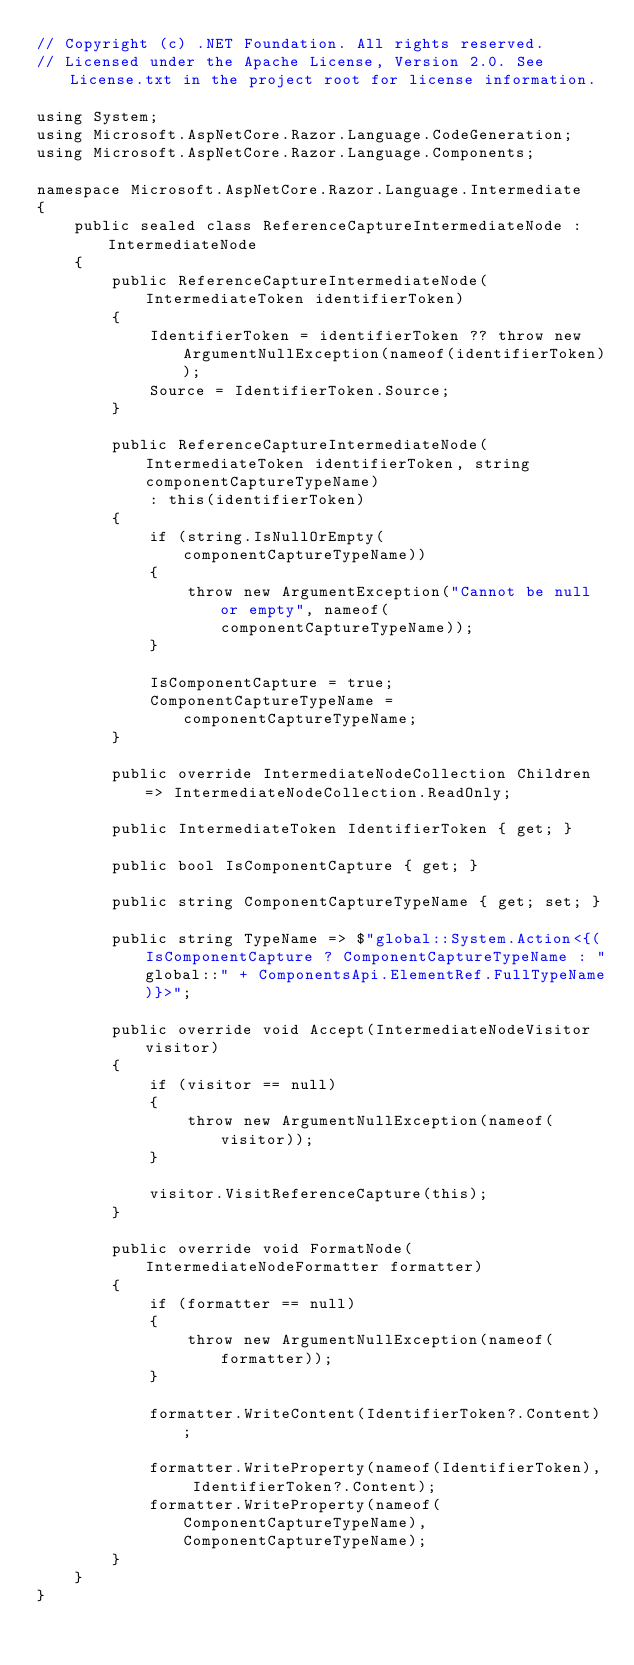<code> <loc_0><loc_0><loc_500><loc_500><_C#_>// Copyright (c) .NET Foundation. All rights reserved.
// Licensed under the Apache License, Version 2.0. See License.txt in the project root for license information.

using System;
using Microsoft.AspNetCore.Razor.Language.CodeGeneration;
using Microsoft.AspNetCore.Razor.Language.Components;

namespace Microsoft.AspNetCore.Razor.Language.Intermediate
{
    public sealed class ReferenceCaptureIntermediateNode : IntermediateNode
    {
        public ReferenceCaptureIntermediateNode(IntermediateToken identifierToken)
        {
            IdentifierToken = identifierToken ?? throw new ArgumentNullException(nameof(identifierToken));
            Source = IdentifierToken.Source;
        }

        public ReferenceCaptureIntermediateNode(IntermediateToken identifierToken, string componentCaptureTypeName)
            : this(identifierToken)
        {
            if (string.IsNullOrEmpty(componentCaptureTypeName))
            {
                throw new ArgumentException("Cannot be null or empty", nameof(componentCaptureTypeName));
            }

            IsComponentCapture = true;
            ComponentCaptureTypeName = componentCaptureTypeName;
        }

        public override IntermediateNodeCollection Children => IntermediateNodeCollection.ReadOnly;

        public IntermediateToken IdentifierToken { get; }

        public bool IsComponentCapture { get; }

        public string ComponentCaptureTypeName { get; set; }

        public string TypeName => $"global::System.Action<{(IsComponentCapture ? ComponentCaptureTypeName : "global::" + ComponentsApi.ElementRef.FullTypeName)}>";

        public override void Accept(IntermediateNodeVisitor visitor)
        {
            if (visitor == null)
            {
                throw new ArgumentNullException(nameof(visitor));
            }

            visitor.VisitReferenceCapture(this);
        }

        public override void FormatNode(IntermediateNodeFormatter formatter)
        {
            if (formatter == null)
            {
                throw new ArgumentNullException(nameof(formatter));
            }
            
            formatter.WriteContent(IdentifierToken?.Content);
            
            formatter.WriteProperty(nameof(IdentifierToken), IdentifierToken?.Content);
            formatter.WriteProperty(nameof(ComponentCaptureTypeName), ComponentCaptureTypeName);
        }
    }
}
</code> 